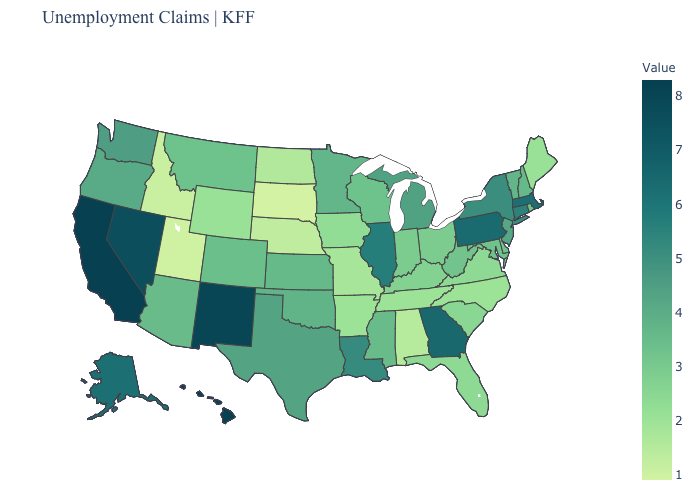Does California have the highest value in the USA?
Short answer required. Yes. Does the map have missing data?
Be succinct. No. Does Minnesota have a lower value than Idaho?
Give a very brief answer. No. Among the states that border South Carolina , which have the highest value?
Write a very short answer. Georgia. Is the legend a continuous bar?
Write a very short answer. Yes. Among the states that border Michigan , does Wisconsin have the highest value?
Answer briefly. Yes. Among the states that border Utah , which have the lowest value?
Quick response, please. Idaho. Among the states that border New Mexico , which have the highest value?
Write a very short answer. Texas. 